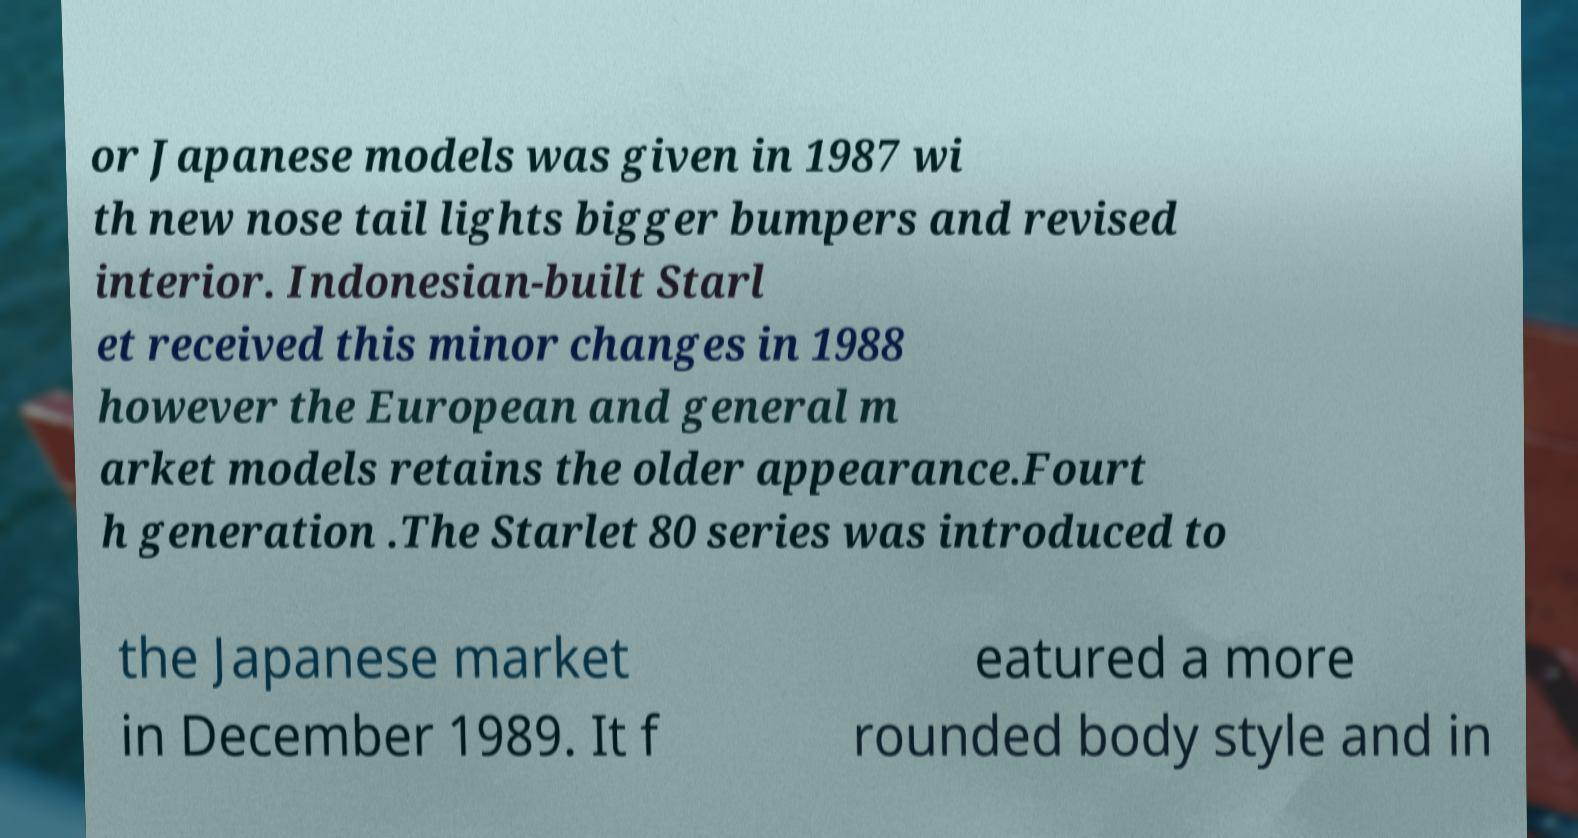Could you assist in decoding the text presented in this image and type it out clearly? or Japanese models was given in 1987 wi th new nose tail lights bigger bumpers and revised interior. Indonesian-built Starl et received this minor changes in 1988 however the European and general m arket models retains the older appearance.Fourt h generation .The Starlet 80 series was introduced to the Japanese market in December 1989. It f eatured a more rounded body style and in 